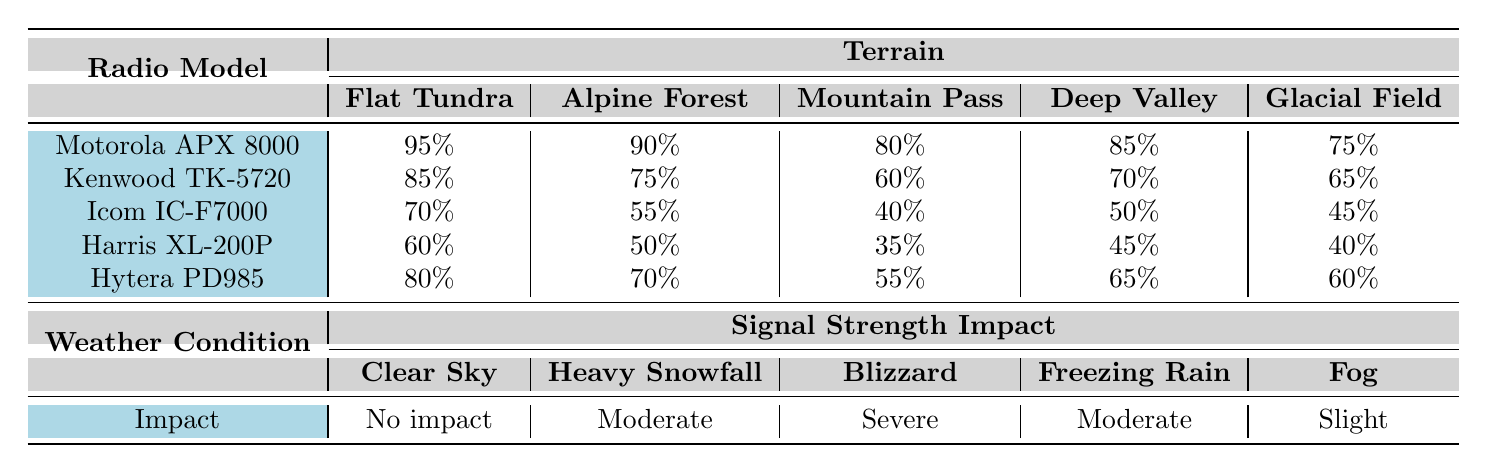What is the signal strength of the Motorola APX 8000 in a Deep Valley? The table indicates the signal strength of the Motorola APX 8000 in the Deep Valley, where the value is listed as 85%.
Answer: 85% In which terrain does the Icom IC-F7000 perform the worst? By looking at the signal strength values for the Icom IC-F7000 across all terrains, the lowest value is 40% in the Mountain Pass, indicating it performs the worst there.
Answer: Mountain Pass What is the average signal strength for the Hytera PD985 across all terrains? Adding the signal strengths for the Hytera PD985: (80 + 70 + 55 + 65 + 60) = 330, and since there are 5 terrains, the average is 330 / 5 = 66.
Answer: 66% Which radio model shows the highest signal strength in Clear Sky conditions? The highest signal strength in Clear Sky conditions is 95% by the Motorola APX 8000.
Answer: Motorola APX 8000 Is there a terrain where the signal strength for the Kenwood TK-5720 is above 80%? The Kenwood TK-5720 shows signal strengths of 85% in Flat Tundra and 70% in Deep Valley. Since there is a 85% in one terrain, the answer is yes.
Answer: Yes What is the signal strength of the Harris XL-200P in heavy snowfall, and how does it compare to the Motorola APX 8000 in the same condition? The Harris XL-200P has a signal strength of 60% in Heavy Snowfall, while the Motorola APX 8000 has a strength of 90%, which is 30% higher.
Answer: 30% higher Which radio model has the least impact under Blizzard conditions? The table shows that the impact on signal strength during a Blizzard is categorized as "Severe." All the radio models will experience this severe impact equally.
Answer: All models equally If the Icom IC-F7000 is used in a Glacial Field, what percentage does it provide, and is that the lowest value for that terrain? The Icom IC-F7000 provides a signal strength of 45% in a Glacial Field. Comparing this with the other radio models, the lowest value for this terrain is actually the Icom IC-F7000 at 45%.
Answer: Yes What is the total signal strength for all radio models in the Flat Tundra? The total signal strength for all models in Flat Tundra is 95 + 85 + 70 + 60 + 80 = 390.
Answer: 390 Which weather condition leads to a "Severe" impact on radio signal strength? The table indicates that "Blizzard" conditions lead to a "Severe" impact on signal strength.
Answer: Blizzard Is the impact of heavy snowfall on radio signal strength more severe than in fog? The table indicates that the impact of Heavy Snowfall is "Moderate," while the impact of Fog is categorized as "Slight." Therefore, the impact of heavy snowfall is indeed more severe.
Answer: Yes 